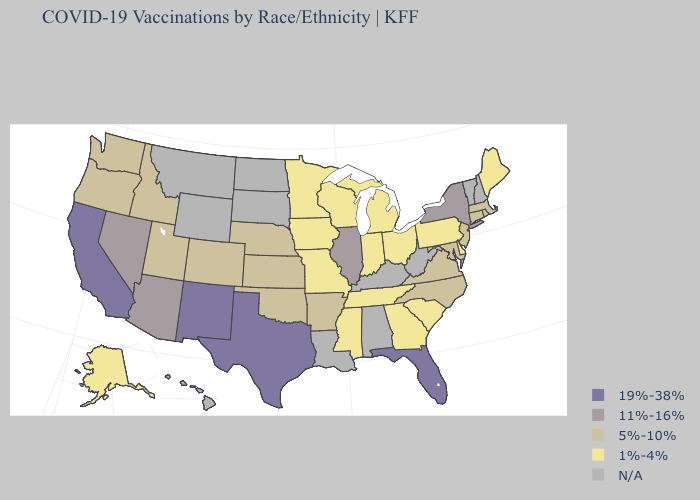What is the value of New Hampshire?
Quick response, please. N/A. What is the highest value in the Northeast ?
Short answer required. 11%-16%. What is the highest value in the USA?
Concise answer only. 19%-38%. What is the highest value in states that border Virginia?
Write a very short answer. 5%-10%. What is the value of New Mexico?
Be succinct. 19%-38%. Among the states that border Minnesota , which have the highest value?
Concise answer only. Iowa, Wisconsin. Does the map have missing data?
Keep it brief. Yes. Name the states that have a value in the range 19%-38%?
Quick response, please. California, Florida, New Mexico, Texas. Among the states that border New York , which have the highest value?
Concise answer only. Connecticut, Massachusetts, New Jersey. What is the value of New Jersey?
Give a very brief answer. 5%-10%. Does South Carolina have the lowest value in the USA?
Be succinct. Yes. How many symbols are there in the legend?
Write a very short answer. 5. Does the map have missing data?
Answer briefly. Yes. Name the states that have a value in the range N/A?
Keep it brief. Alabama, Hawaii, Kentucky, Louisiana, Montana, New Hampshire, North Dakota, South Dakota, Vermont, West Virginia, Wyoming. 